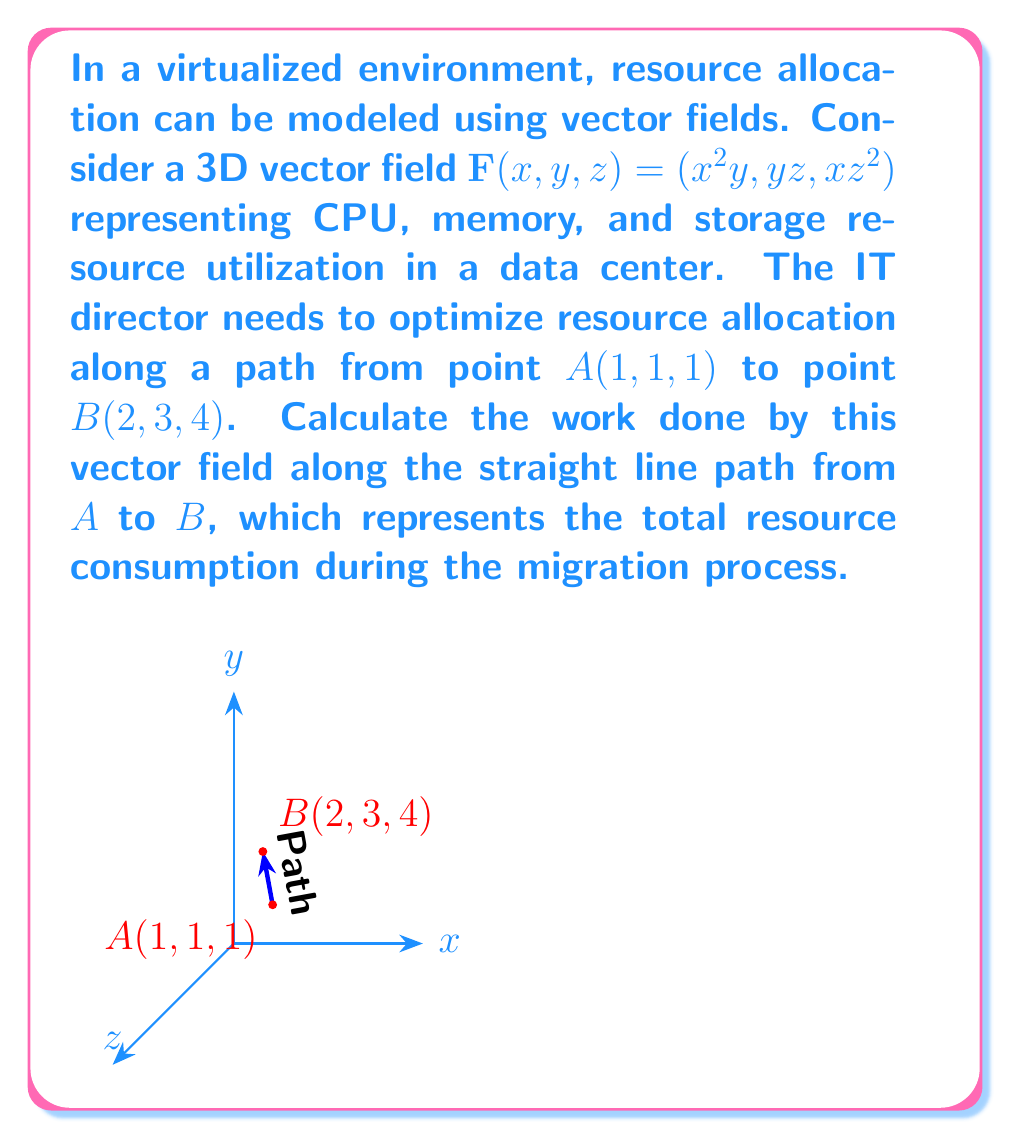What is the answer to this math problem? To solve this problem, we'll follow these steps:

1) The vector field is given by $\mathbf{F}(x, y, z) = (x^2y, yz, xz^2)$.

2) We need to calculate the line integral of this vector field along the straight line from $A(1, 1, 1)$ to $B(2, 3, 4)$.

3) Parametrize the line path:
   $\mathbf{r}(t) = (1, 1, 1) + t(1, 2, 3)$, where $0 \leq t \leq 1$
   So, $x = 1 + t$, $y = 1 + 2t$, $z = 1 + 3t$

4) Calculate $\frac{d\mathbf{r}}{dt} = (1, 2, 3)$

5) The line integral is given by:
   $$\int_C \mathbf{F} \cdot d\mathbf{r} = \int_0^1 \mathbf{F}(\mathbf{r}(t)) \cdot \frac{d\mathbf{r}}{dt} dt$$

6) Substitute the parametrized values into $\mathbf{F}$:
   $\mathbf{F}(\mathbf{r}(t)) = ((1+t)^2(1+2t), (1+2t)(1+3t), (1+t)(1+3t)^2)$

7) Calculate the dot product:
   $\mathbf{F}(\mathbf{r}(t)) \cdot \frac{d\mathbf{r}}{dt} = (1+t)^2(1+2t) \cdot 1 + (1+2t)(1+3t) \cdot 2 + (1+t)(1+3t)^2 \cdot 3$

8) Simplify and integrate:
   $$\int_0^1 [(1+t)^2(1+2t) + 2(1+2t)(1+3t) + 3(1+t)(1+3t)^2] dt$$

9) Expand and integrate term by term:
   $$\int_0^1 [1 + 4t + 5t^2 + 2t^3 + 2 + 10t + 12t^2 + 3 + 21t + 45t^2 + 27t^3] dt$$
   $$= \int_0^1 [6 + 35t + 62t^2 + 29t^3] dt$$

10) Evaluate the integral:
    $$[6t + \frac{35}{2}t^2 + \frac{62}{3}t^3 + \frac{29}{4}t^4]_0^1$$
    $$= (6 + \frac{35}{2} + \frac{62}{3} + \frac{29}{4}) - 0 = \frac{739}{12} \approx 61.58$$

Therefore, the work done by the vector field along the path, representing the total resource consumption during the migration process, is $\frac{739}{12}$ resource units.
Answer: $\frac{739}{12}$ resource units 